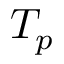Convert formula to latex. <formula><loc_0><loc_0><loc_500><loc_500>T _ { p }</formula> 